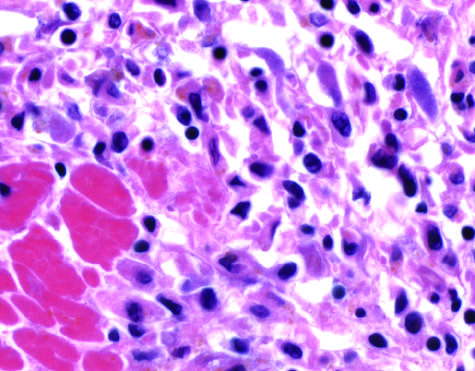where do the photomicrographs show an inflammatory reaction after ischemic necrosis infarction?
Answer the question using a single word or phrase. In the myocardium 